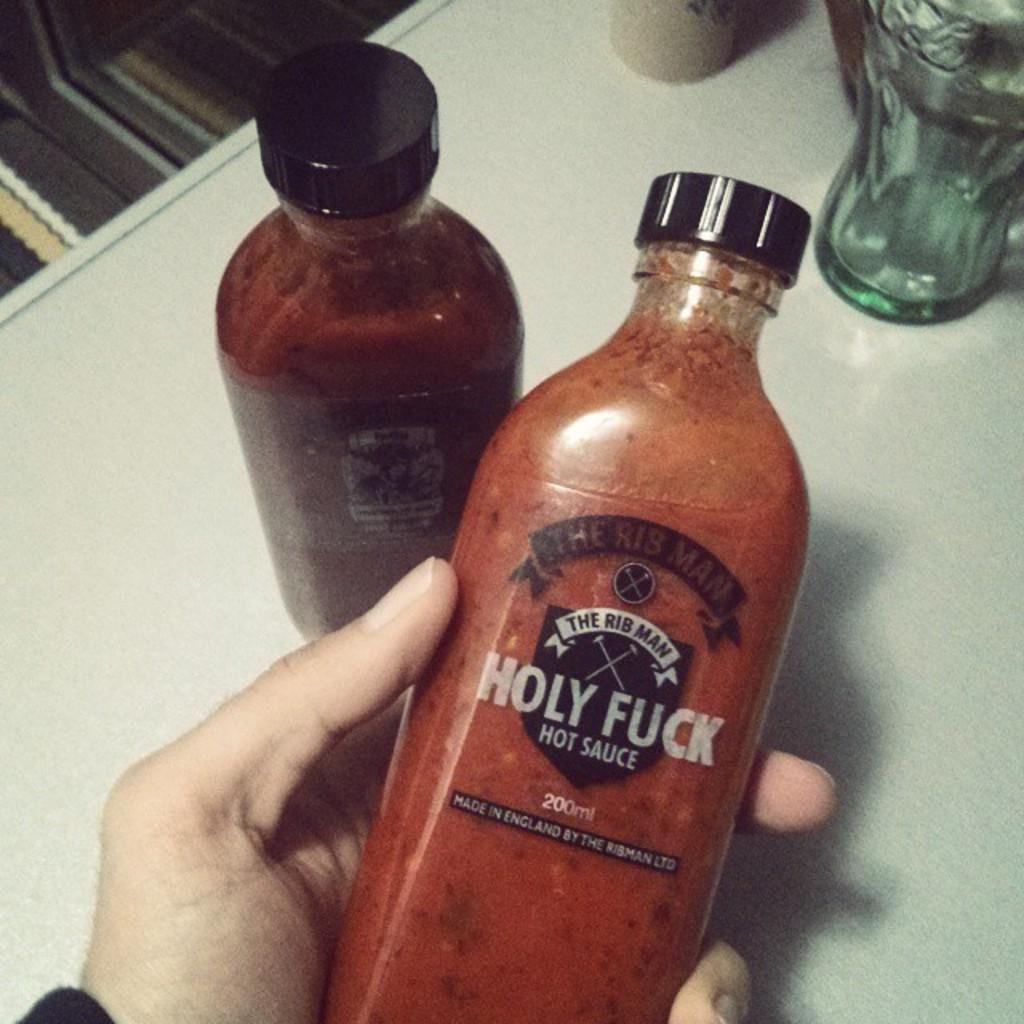How many milliliters does this bottle have?
Your answer should be compact. 200. 